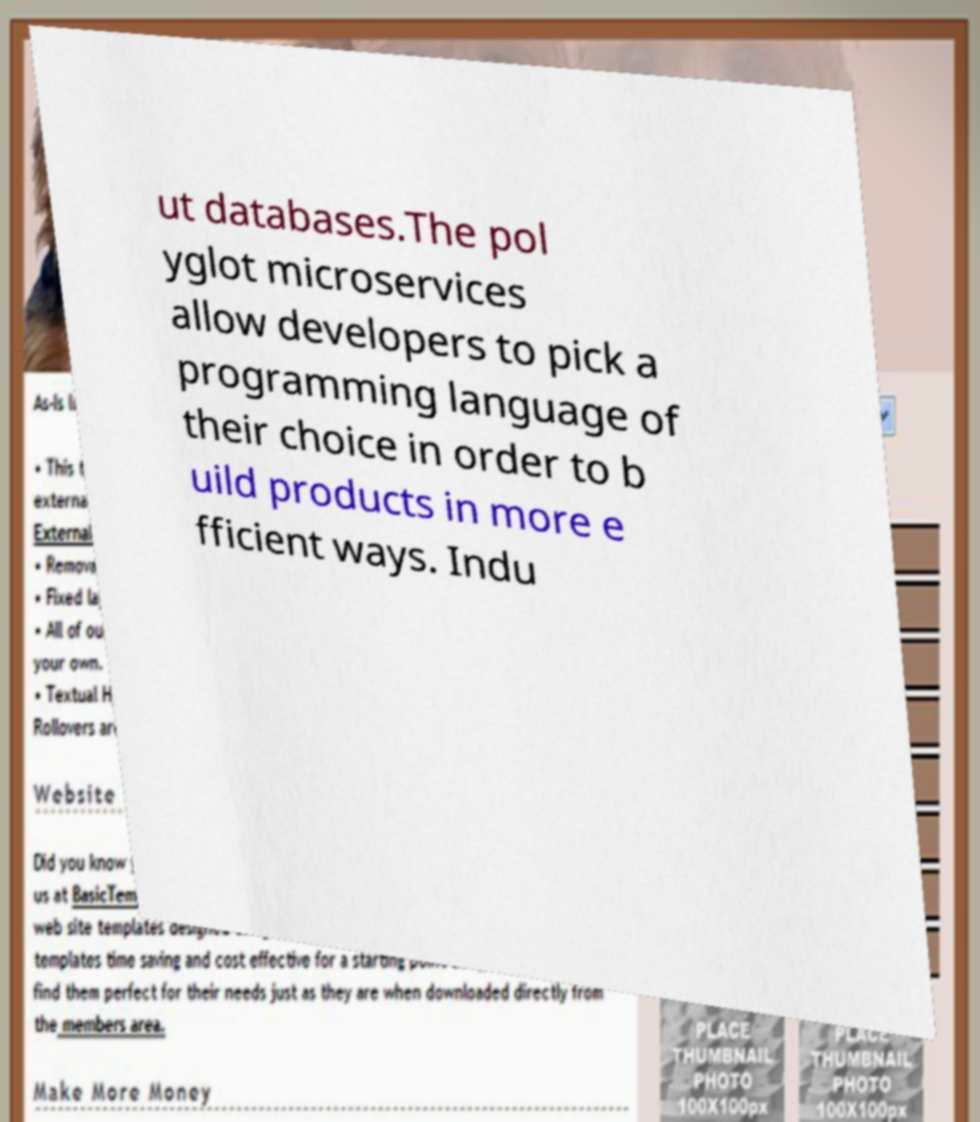There's text embedded in this image that I need extracted. Can you transcribe it verbatim? ut databases.The pol yglot microservices allow developers to pick a programming language of their choice in order to b uild products in more e fficient ways. Indu 